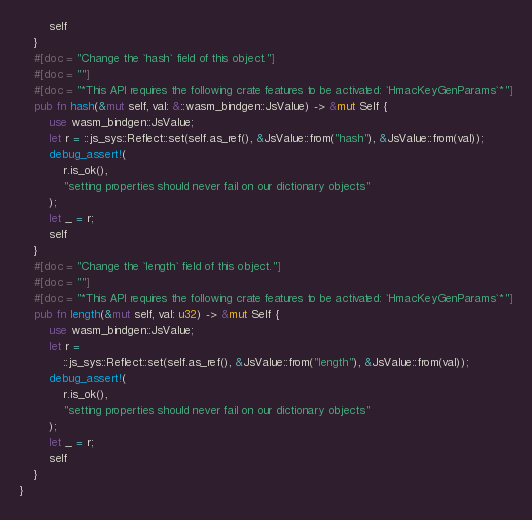<code> <loc_0><loc_0><loc_500><loc_500><_Rust_>        self
    }
    #[doc = "Change the `hash` field of this object."]
    #[doc = ""]
    #[doc = "*This API requires the following crate features to be activated: `HmacKeyGenParams`*"]
    pub fn hash(&mut self, val: &::wasm_bindgen::JsValue) -> &mut Self {
        use wasm_bindgen::JsValue;
        let r = ::js_sys::Reflect::set(self.as_ref(), &JsValue::from("hash"), &JsValue::from(val));
        debug_assert!(
            r.is_ok(),
            "setting properties should never fail on our dictionary objects"
        );
        let _ = r;
        self
    }
    #[doc = "Change the `length` field of this object."]
    #[doc = ""]
    #[doc = "*This API requires the following crate features to be activated: `HmacKeyGenParams`*"]
    pub fn length(&mut self, val: u32) -> &mut Self {
        use wasm_bindgen::JsValue;
        let r =
            ::js_sys::Reflect::set(self.as_ref(), &JsValue::from("length"), &JsValue::from(val));
        debug_assert!(
            r.is_ok(),
            "setting properties should never fail on our dictionary objects"
        );
        let _ = r;
        self
    }
}
</code> 